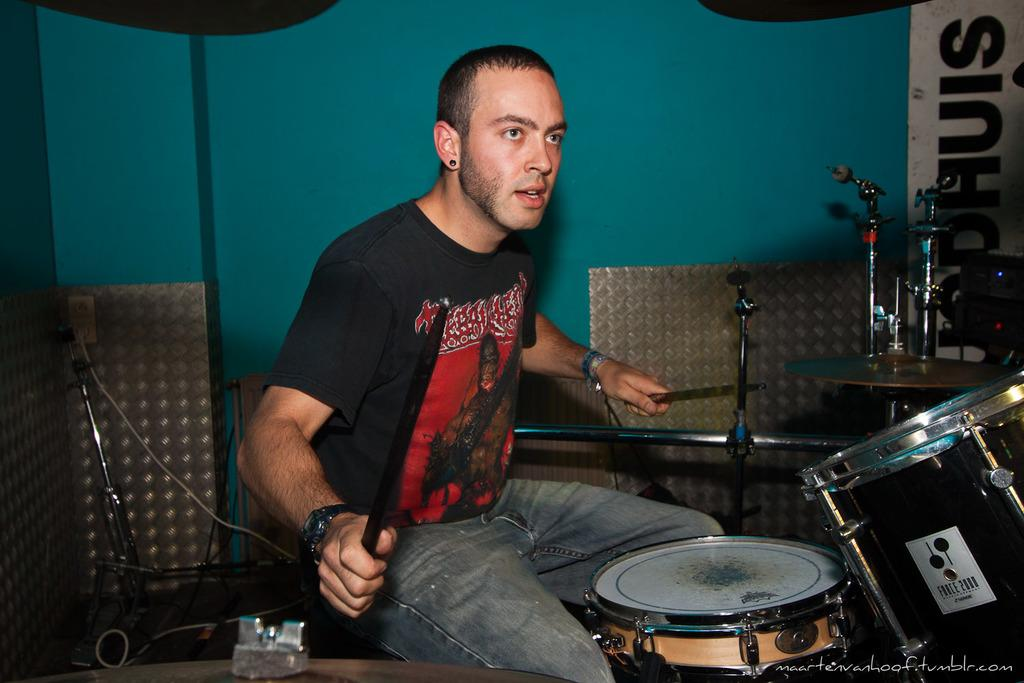What is the man in the image doing? The man is sitting on a chair in the image. What object is the man holding in his hand? The man is holding a stick in his hand. What musical instruments are present in the image? There are two drums in the image. What device is used for amplifying sound in the image? There is a microphone on a table in the image. What color is the wall in the image? The wall is blue in color. What type of train can be seen passing by in the image? There is no train present in the image; it features a man sitting on a chair with a stick and musical instruments. What material is the twig made of in the image? There is no twig present in the image; the man is holding a stick, but its material is not specified. 